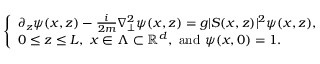Convert formula to latex. <formula><loc_0><loc_0><loc_500><loc_500>\left \{ \begin{array} { l } { \partial _ { z } \psi ( x , z ) - \frac { i } { 2 m } \nabla _ { \perp } ^ { 2 } \psi ( x , z ) = g | S ( x , z ) | ^ { 2 } \psi ( x , z ) , } \\ { 0 \leq z \leq L , \ x \in \Lambda \subset \mathbb { R } ^ { d } , \ a n d \ \psi ( x , 0 ) = 1 . } \end{array}</formula> 